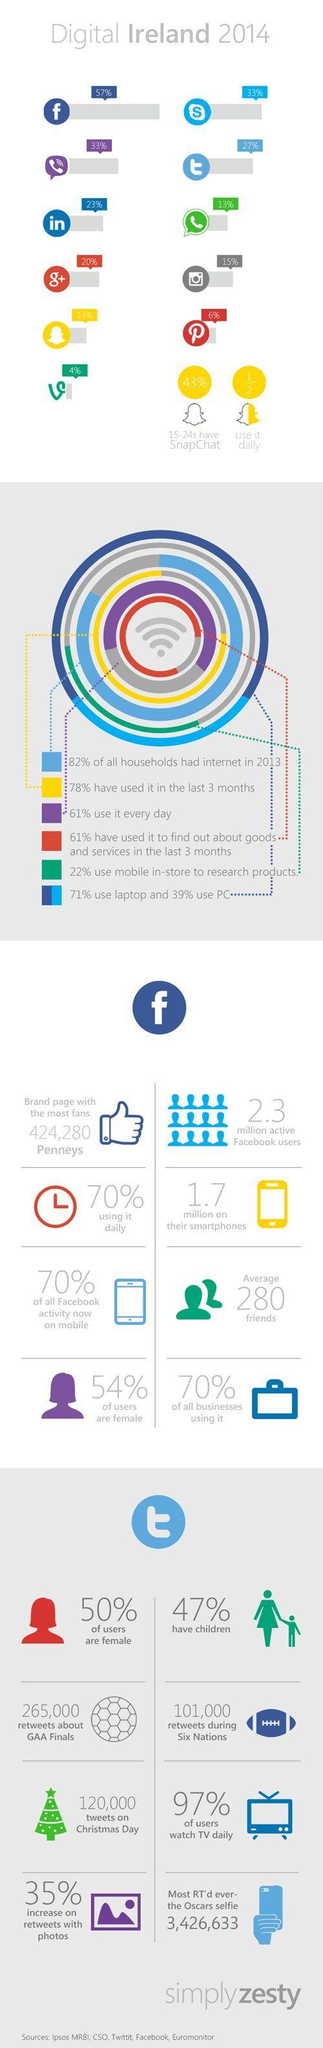Identify some key points in this picture. In 2014, it was reported that 46% of Facebook users in Ireland were male. In 2014, it was reported that 23% of the LinkedIn users were based in Ireland. In 2014, it was estimated that 13% of the population in Ireland used WhatsApp. According to data, only 3% of Twitter users in Ireland do not watch TV daily. According to a survey conducted in 2014, 61% of the Irish population used Viber on a daily basis. 